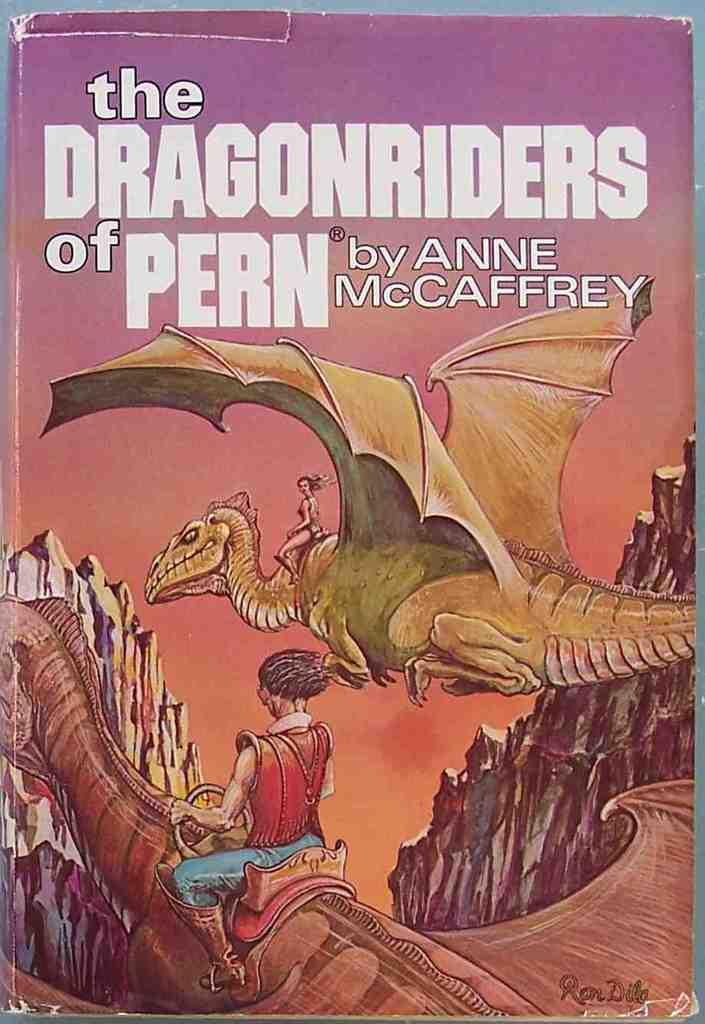Provide a one-sentence caption for the provided image. The Dragonriders of Pern is the title of this science fiction, paper back book. 